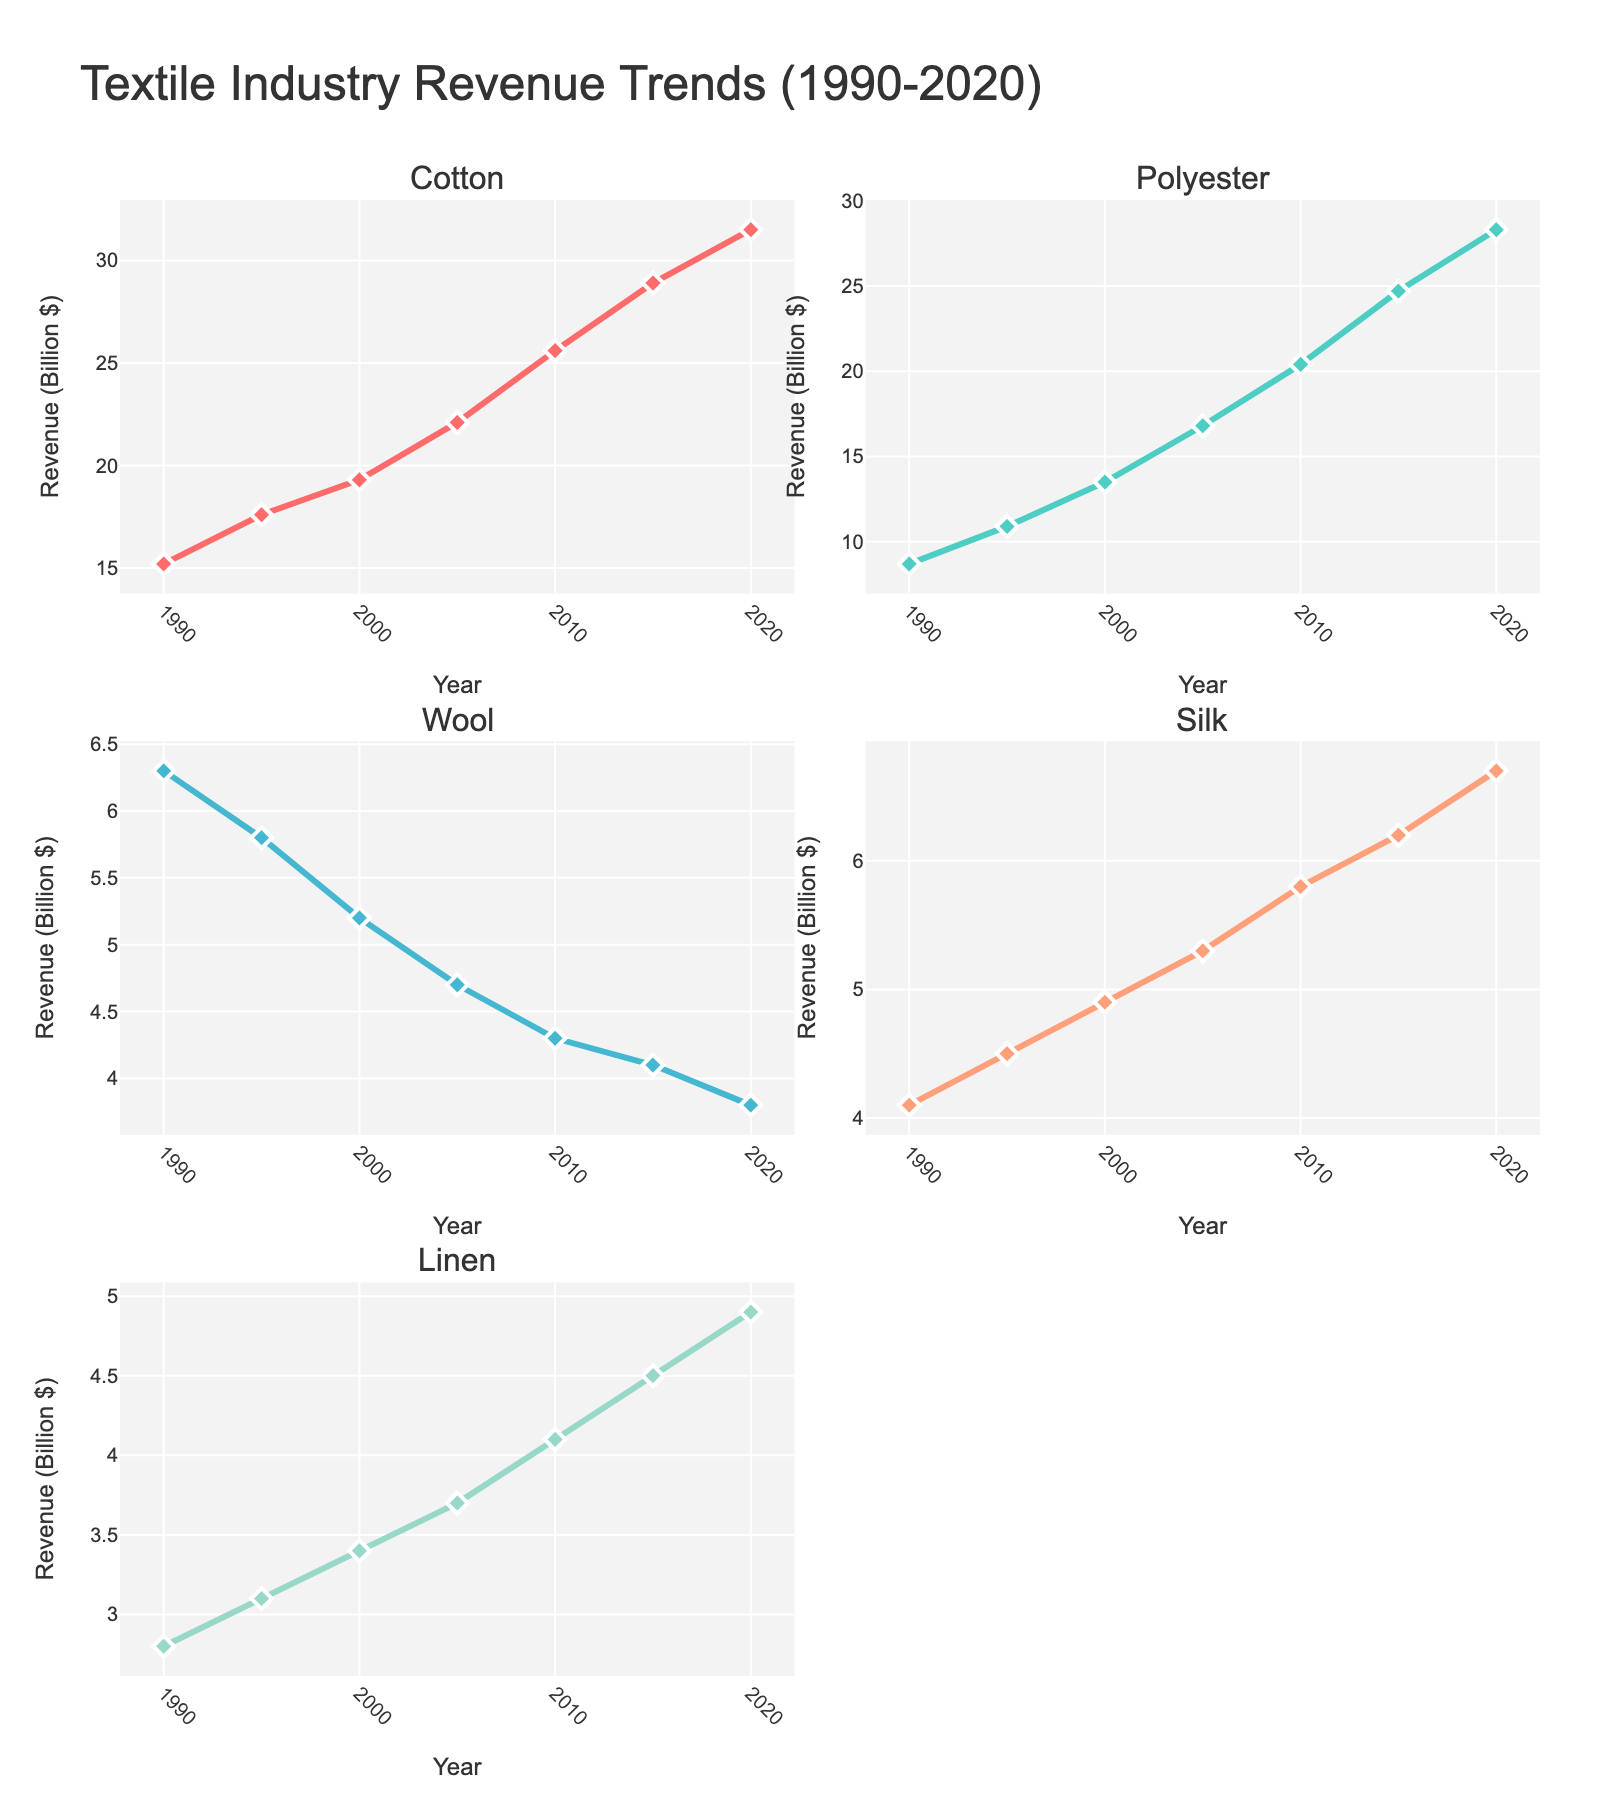What's the title of the figure? The title is located at the top of the figure and provides an overview of what the figure represents.
Answer: Textile Industry Revenue Trends (1990-2020) How many fabric types are shown in the figure? There are individual subplots for each fabric type. By counting the subplot titles, we can determine the number of fabric types.
Answer: 5 During which year did Cotton exceed 20 billion dollars in revenue? By looking at the line chart for Cotton, we can track the revenue values over the years. Cotton exceeds 20 billion dollars in 2005.
Answer: 2005 Which fabric type had the least revenue in 2020? To determine this, compare the endpoint of all the line charts for the year 2020. Wool has the lowest endpoint value.
Answer: Wool What was the revenue difference between Polyester and Silk in 2010? Locate the points for Polyester and Silk in 2010 and subtract the smaller value from the larger value: Polyester (20.4) - Silk (5.8) = 14.6.
Answer: 14.6 billion dollars Which fabric type had the most significant revenue growth from 1990 to 2020? Calculate the difference between 2020 and 1990 revenue values for each fabric type. Cotton had the largest increase: 31.5 - 15.2 = 16.3 billion dollars.
Answer: Cotton How many major trends (increasing or decreasing) can you observe in Wool's revenue over the years? Check the line chart for Wool to count the distinct periods of increasing or decreasing trends. There are 2 trends (decreasing overall but slight increase between some periods).
Answer: 2 What is the average revenue of Linen from 1990 to 2020? Sum the revenue values of Linen across all years and divide by the number of years: (2.8 + 3.1 + 3.4 + 3.7 + 4.1 + 4.5 + 4.9) / 7 = 3.64.
Answer: 3.64 billion dollars Did Silk ever surpass Wool in revenue during the given period? Compare the values of Silk and Wool year by year to see if Silk's line ever goes above Wool's line. Silk surpassed Wool starting from 2005.
Answer: Yes Which fabric type shows a consistent increase in revenue across all years without any drops? Examine the trend lines for each fabric. Cotton and Polyester show consistent increases without any drops each year.
Answer: Cotton and Polyester 